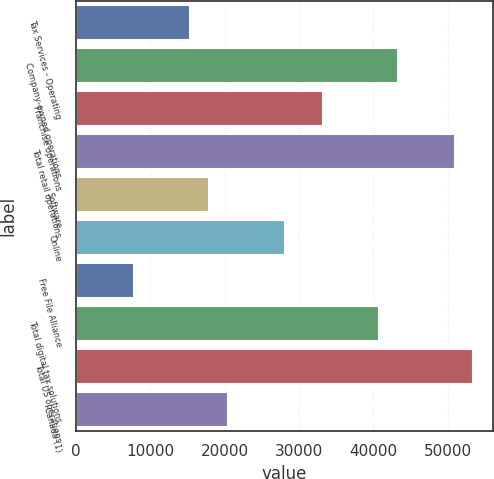<chart> <loc_0><loc_0><loc_500><loc_500><bar_chart><fcel>Tax Services - Operating<fcel>Company-owned operations<fcel>Franchise operations<fcel>Total retail operations<fcel>Software<fcel>Online<fcel>Free File Alliance<fcel>Total digital tax solutions<fcel>Total US operations<fcel>Canada (1)<nl><fcel>15402.4<fcel>43319.3<fcel>33167.7<fcel>50933<fcel>17940.3<fcel>28091.9<fcel>7788.7<fcel>40781.4<fcel>53470.9<fcel>20478.2<nl></chart> 